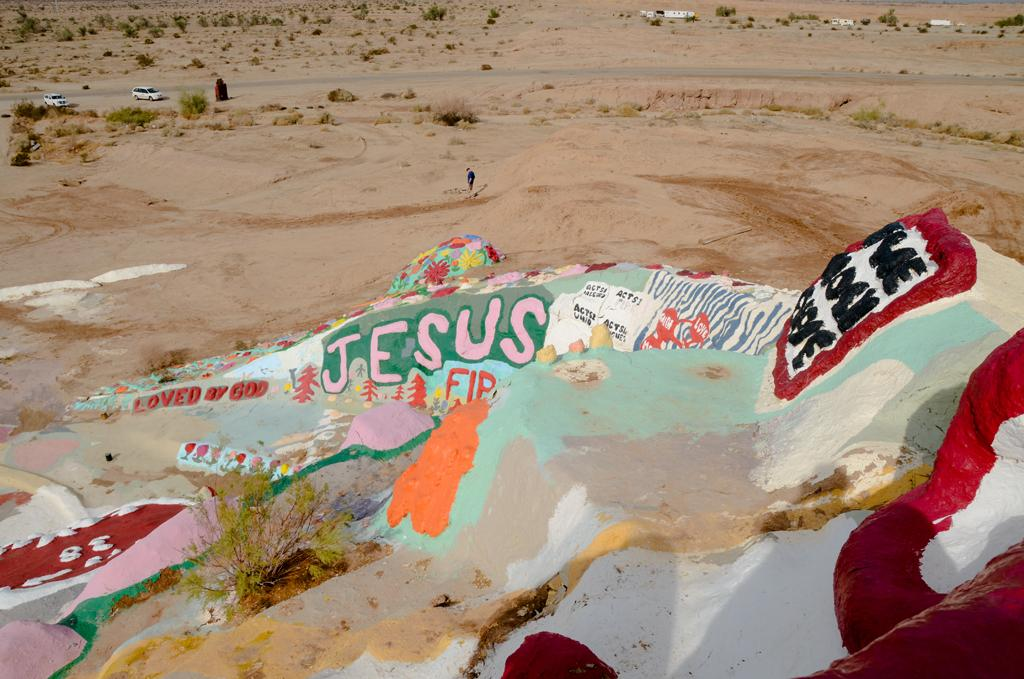What can be observed about the sand in the image? There are different colors of sand in the image. What is the main subject in the middle of the image? A person is standing in the middle of the image. What type of objects are on the left side of the image? There are two vehicles on the left side of the image. What color are the vehicles? The vehicles are white in color. What type of marble is present in the image? There is no marble present in the image. Does the existence of the person in the image prove the existence of extraterrestrial life? The presence of a person in the image does not prove the existence of extraterrestrial life, as the person appears to be human. 